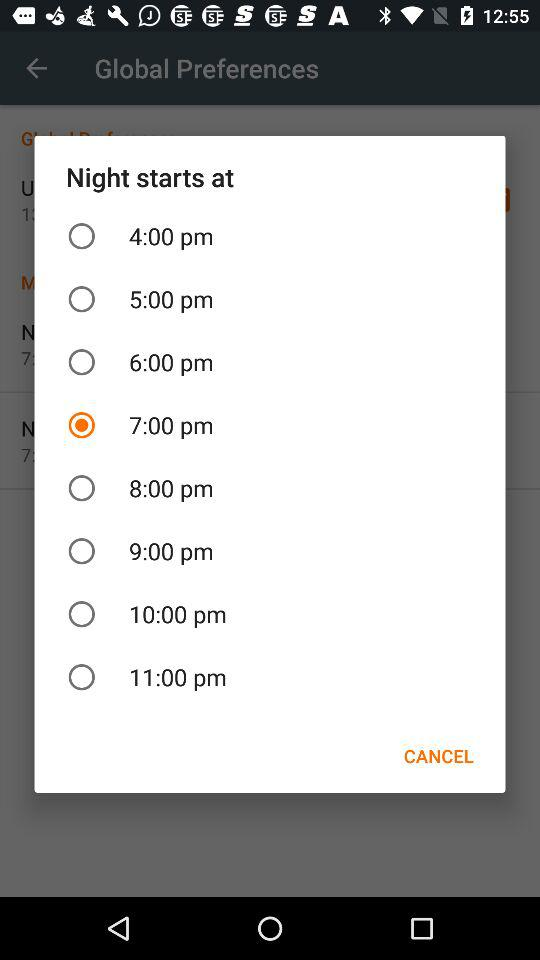At what time does the night start? The night starts at 7:00 pm. 